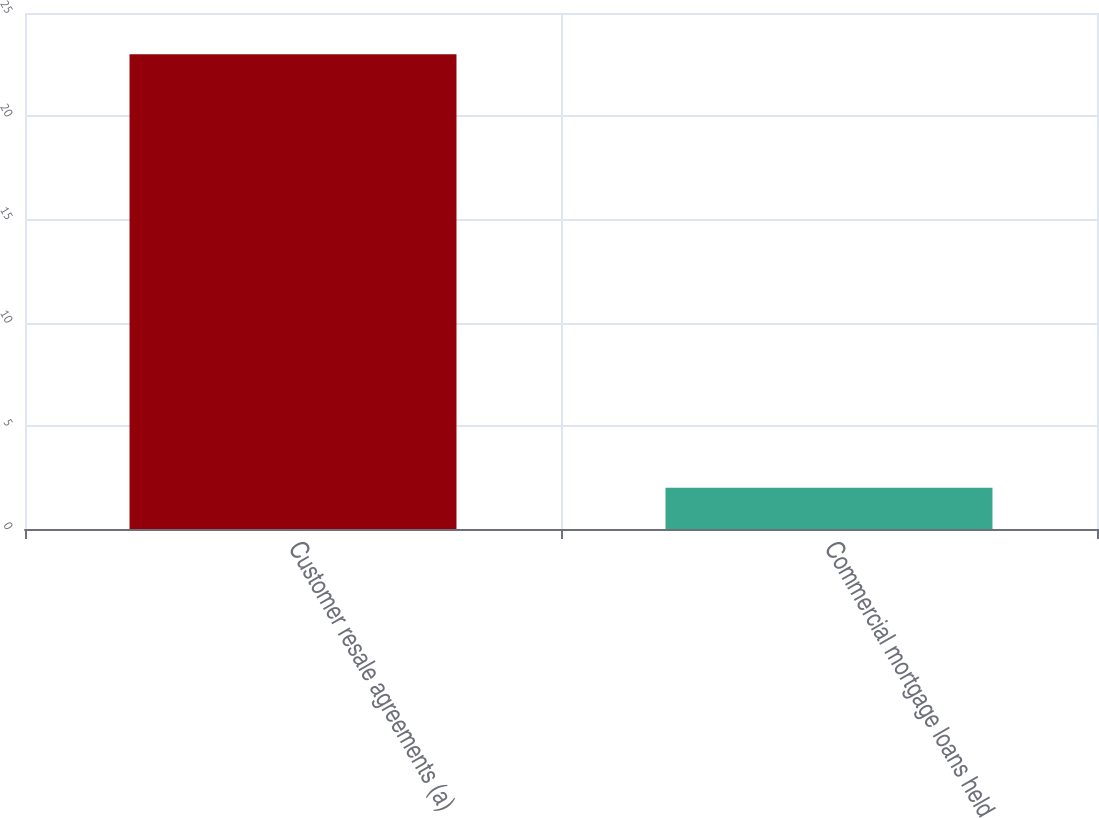<chart> <loc_0><loc_0><loc_500><loc_500><bar_chart><fcel>Customer resale agreements (a)<fcel>Commercial mortgage loans held<nl><fcel>23<fcel>2<nl></chart> 